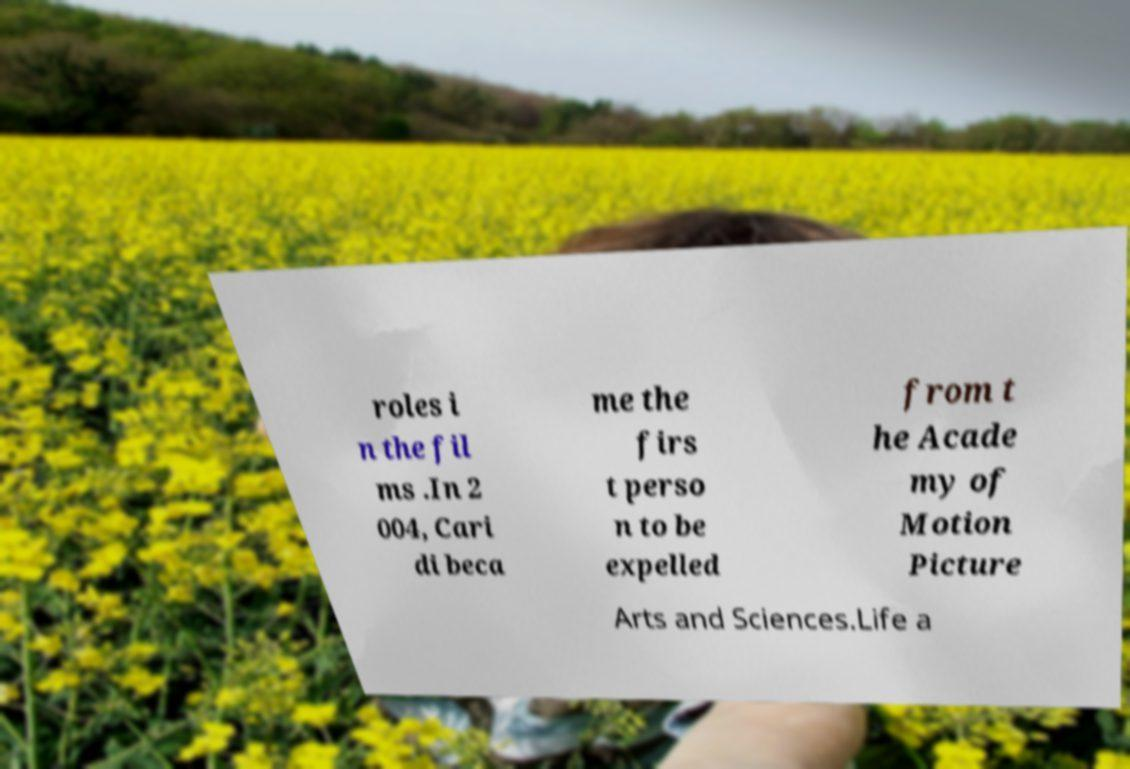Can you accurately transcribe the text from the provided image for me? roles i n the fil ms .In 2 004, Cari di beca me the firs t perso n to be expelled from t he Acade my of Motion Picture Arts and Sciences.Life a 